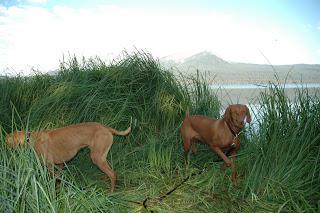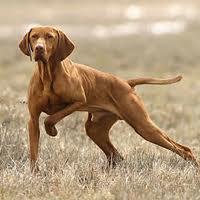The first image is the image on the left, the second image is the image on the right. For the images shown, is this caption "In one image there is a single dog and in the other image there are 2 dogs." true? Answer yes or no. Yes. The first image is the image on the left, the second image is the image on the right. Examine the images to the left and right. Is the description "One of the images features a pair of dogs together." accurate? Answer yes or no. Yes. 